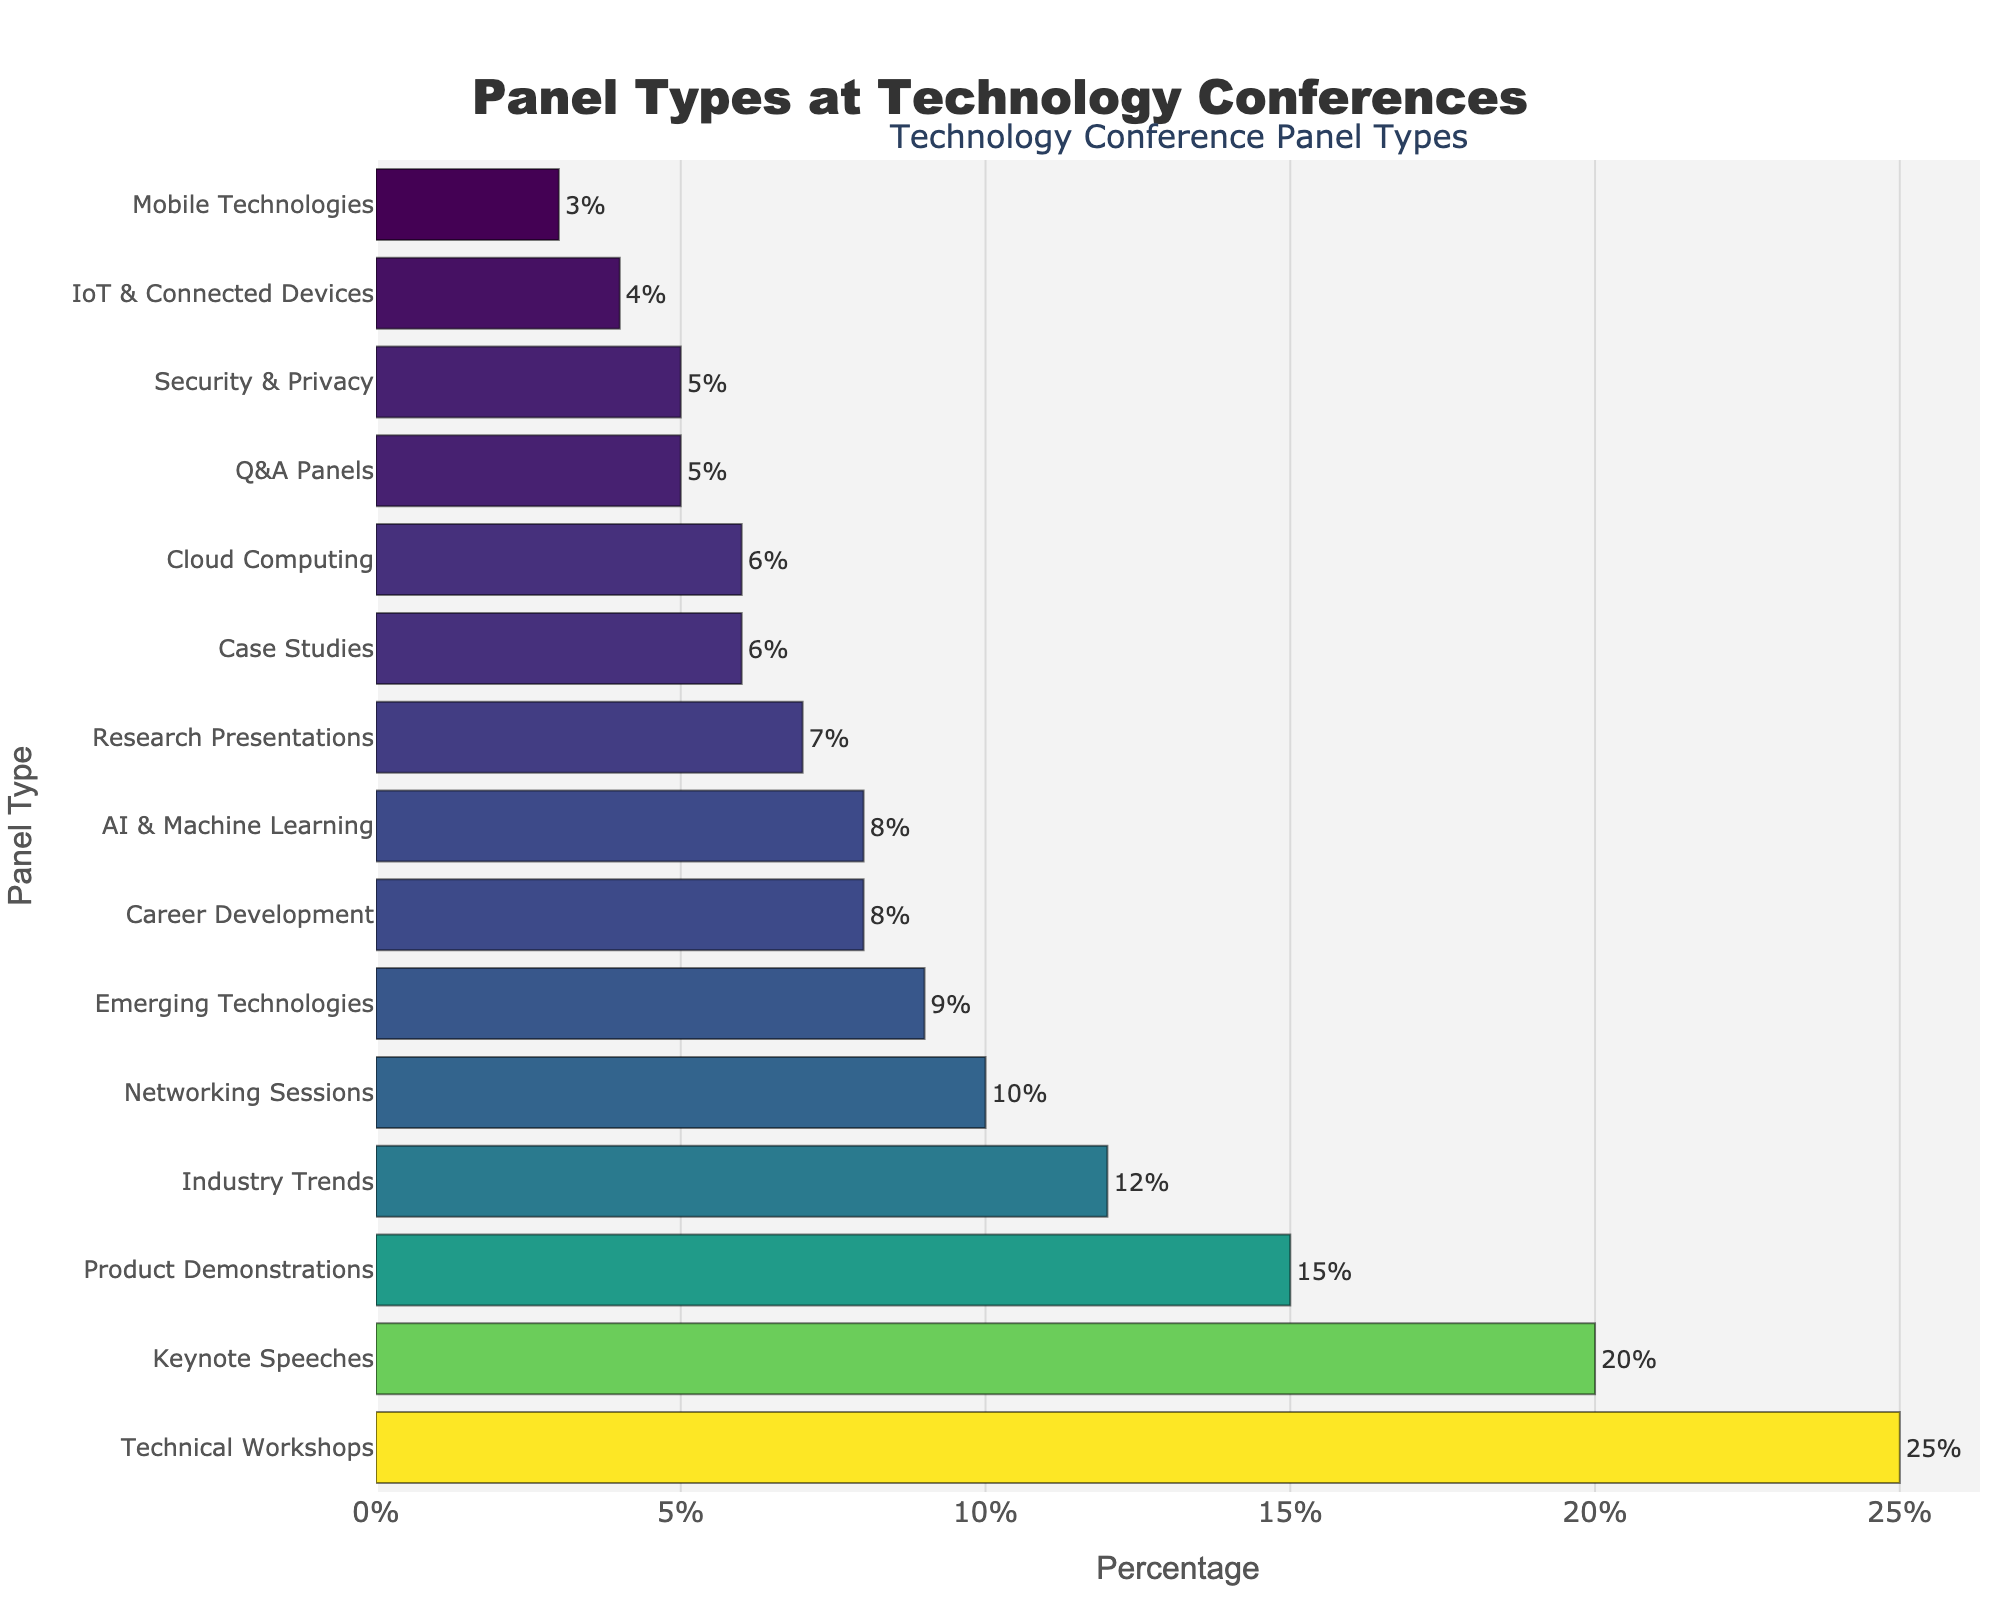Which panel type is offered the most at technology conferences? Observing the bar chart, the 'Technical Workshops' panel has the highest length, indicating it has the highest percentage.
Answer: Technical Workshops Which panel type is offered less, Career Development or AI & Machine Learning? By comparing the lengths of the bars, 'Career Development' has a percentage of 8%, while 'AI & Machine Learning' also has a percentage of 8%. Both are equal.
Answer: Both are equal What is the total percentage of the three least offered panel types? Identifying the three shortest bars, 'Mobile Technologies' (3%), 'IoT & Connected Devices' (4%), and 'Q&A Panels' (5%). Summing them up, 3 + 4 + 5 = 12.
Answer: 12% How does the percentage of Product Demonstrations compare with Security & Privacy? Looking at the bars, 'Product Demonstrations' is at 15%, and 'Security & Privacy' is at 5%. Therefore, Product Demonstrations are offered 10% more.
Answer: 10% more What is the average percentage of panels that are offered under 10%? Identifying the panels with percentages under 10%, they are: 'Industry Trends' (12), 'Career Development' (8), 'Networking Sessions' (10), 'Research Presentations' (7), 'Q&A Panels' (5), 'Case Studies' (6), 'Emerging Technologies' (9), 'Security & Privacy' (5), 'IoT & Connected Devices' (4), 'Cloud Computing' (6), and 'Mobile Technologies' (3). Calculating the average by summing 8+10+7+5+6+9+5+4+6+3 and dividing by 10, (63/10)= 6.3.
Answer: 6.3% Which panel type has a percentage closest to Industry Trends? 'Industry Trends' is at 12%. 'Networking Sessions' has 10%, and 'Emerging Technologies' has 9%. By comparison, 10% is the closest.
Answer: Networking Sessions How many panel types have a percentage greater than 6% but less than 15%? Observing the range, the panel types fitting this range are: 'Product Demonstrations' (15), 'Industry Trends' (12), 'Networking Sessions' (10), 'Career Development' (8), 'Research Presentations' (7), 'Emerging Technologies' (9), and 'Cloud Computing' (6). There are 6 such panels.
Answer: 6 Which panel type has a percentage twice as much as Security & Privacy? 'Security & Privacy' is at 5%. The panel type with 10% is 'Networking Sessions', which is exactly twice 5%.
Answer: Networking Sessions What is the combined percentage of Keynote Speeches and Technical Workshops? 'Keynote Speeches' has 20% and 'Technical Workshops' has 25%. Summing them up, 20 + 25 = 45.
Answer: 45% Which panel type falls directly between Technical Workshops and Product Demonstrations in percentage terms? 'Technical Workshops' stands at 25% and 'Product Demonstrations' at 15%. 'Keynote Speeches' with 20% falls directly between them.
Answer: Keynote Speeches 